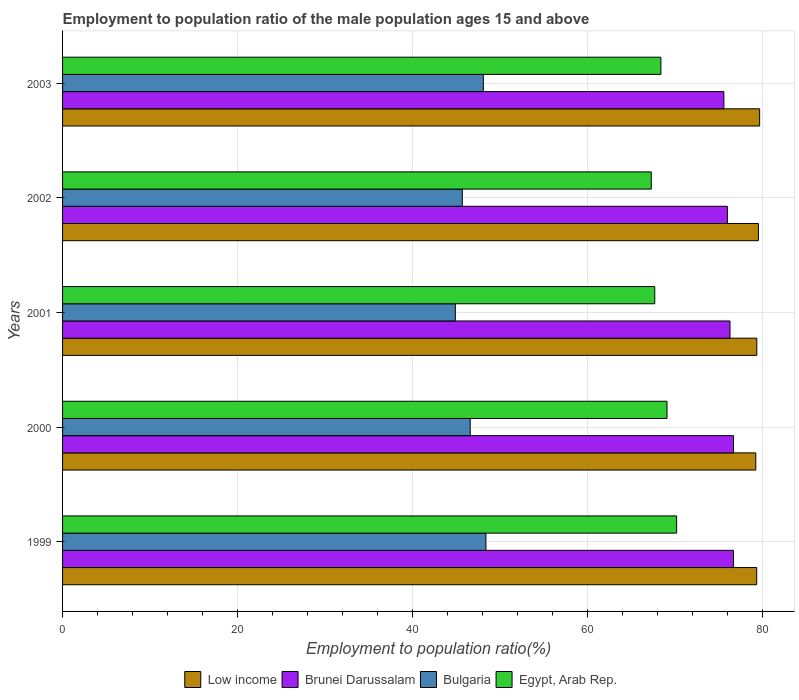Are the number of bars per tick equal to the number of legend labels?
Offer a very short reply. Yes. What is the label of the 3rd group of bars from the top?
Your answer should be compact. 2001. What is the employment to population ratio in Egypt, Arab Rep. in 1999?
Make the answer very short. 70.2. Across all years, what is the maximum employment to population ratio in Brunei Darussalam?
Your response must be concise. 76.7. Across all years, what is the minimum employment to population ratio in Bulgaria?
Your answer should be compact. 44.9. In which year was the employment to population ratio in Bulgaria maximum?
Provide a succinct answer. 1999. What is the total employment to population ratio in Low income in the graph?
Provide a short and direct response. 397.2. What is the difference between the employment to population ratio in Bulgaria in 1999 and that in 2001?
Your answer should be very brief. 3.5. What is the difference between the employment to population ratio in Bulgaria in 2001 and the employment to population ratio in Low income in 2003?
Provide a succinct answer. -34.79. What is the average employment to population ratio in Brunei Darussalam per year?
Offer a terse response. 76.26. In the year 1999, what is the difference between the employment to population ratio in Bulgaria and employment to population ratio in Low income?
Provide a succinct answer. -30.95. In how many years, is the employment to population ratio in Brunei Darussalam greater than 20 %?
Your answer should be compact. 5. What is the ratio of the employment to population ratio in Brunei Darussalam in 2001 to that in 2002?
Provide a succinct answer. 1. What is the difference between the highest and the second highest employment to population ratio in Low income?
Provide a short and direct response. 0.14. What is the difference between the highest and the lowest employment to population ratio in Low income?
Ensure brevity in your answer.  0.44. In how many years, is the employment to population ratio in Brunei Darussalam greater than the average employment to population ratio in Brunei Darussalam taken over all years?
Keep it short and to the point. 3. Is the sum of the employment to population ratio in Brunei Darussalam in 2000 and 2001 greater than the maximum employment to population ratio in Low income across all years?
Your response must be concise. Yes. What does the 3rd bar from the top in 2003 represents?
Your answer should be compact. Brunei Darussalam. What does the 2nd bar from the bottom in 2001 represents?
Your answer should be very brief. Brunei Darussalam. Is it the case that in every year, the sum of the employment to population ratio in Low income and employment to population ratio in Brunei Darussalam is greater than the employment to population ratio in Bulgaria?
Your answer should be compact. Yes. What is the difference between two consecutive major ticks on the X-axis?
Your response must be concise. 20. Are the values on the major ticks of X-axis written in scientific E-notation?
Offer a very short reply. No. Where does the legend appear in the graph?
Offer a terse response. Bottom center. How many legend labels are there?
Your answer should be very brief. 4. How are the legend labels stacked?
Make the answer very short. Horizontal. What is the title of the graph?
Make the answer very short. Employment to population ratio of the male population ages 15 and above. What is the label or title of the Y-axis?
Provide a short and direct response. Years. What is the Employment to population ratio(%) in Low income in 1999?
Your answer should be very brief. 79.35. What is the Employment to population ratio(%) of Brunei Darussalam in 1999?
Make the answer very short. 76.7. What is the Employment to population ratio(%) of Bulgaria in 1999?
Ensure brevity in your answer.  48.4. What is the Employment to population ratio(%) of Egypt, Arab Rep. in 1999?
Make the answer very short. 70.2. What is the Employment to population ratio(%) in Low income in 2000?
Your answer should be compact. 79.25. What is the Employment to population ratio(%) in Brunei Darussalam in 2000?
Your response must be concise. 76.7. What is the Employment to population ratio(%) of Bulgaria in 2000?
Make the answer very short. 46.6. What is the Employment to population ratio(%) of Egypt, Arab Rep. in 2000?
Ensure brevity in your answer.  69.1. What is the Employment to population ratio(%) of Low income in 2001?
Keep it short and to the point. 79.36. What is the Employment to population ratio(%) in Brunei Darussalam in 2001?
Your response must be concise. 76.3. What is the Employment to population ratio(%) of Bulgaria in 2001?
Your response must be concise. 44.9. What is the Employment to population ratio(%) in Egypt, Arab Rep. in 2001?
Provide a succinct answer. 67.7. What is the Employment to population ratio(%) of Low income in 2002?
Give a very brief answer. 79.55. What is the Employment to population ratio(%) of Brunei Darussalam in 2002?
Offer a terse response. 76. What is the Employment to population ratio(%) of Bulgaria in 2002?
Ensure brevity in your answer.  45.7. What is the Employment to population ratio(%) in Egypt, Arab Rep. in 2002?
Your answer should be compact. 67.3. What is the Employment to population ratio(%) of Low income in 2003?
Your response must be concise. 79.69. What is the Employment to population ratio(%) of Brunei Darussalam in 2003?
Offer a very short reply. 75.6. What is the Employment to population ratio(%) of Bulgaria in 2003?
Make the answer very short. 48.1. What is the Employment to population ratio(%) in Egypt, Arab Rep. in 2003?
Give a very brief answer. 68.4. Across all years, what is the maximum Employment to population ratio(%) of Low income?
Keep it short and to the point. 79.69. Across all years, what is the maximum Employment to population ratio(%) in Brunei Darussalam?
Give a very brief answer. 76.7. Across all years, what is the maximum Employment to population ratio(%) of Bulgaria?
Provide a succinct answer. 48.4. Across all years, what is the maximum Employment to population ratio(%) of Egypt, Arab Rep.?
Your answer should be compact. 70.2. Across all years, what is the minimum Employment to population ratio(%) of Low income?
Provide a short and direct response. 79.25. Across all years, what is the minimum Employment to population ratio(%) of Brunei Darussalam?
Keep it short and to the point. 75.6. Across all years, what is the minimum Employment to population ratio(%) of Bulgaria?
Your response must be concise. 44.9. Across all years, what is the minimum Employment to population ratio(%) in Egypt, Arab Rep.?
Make the answer very short. 67.3. What is the total Employment to population ratio(%) in Low income in the graph?
Your answer should be compact. 397.2. What is the total Employment to population ratio(%) in Brunei Darussalam in the graph?
Your answer should be very brief. 381.3. What is the total Employment to population ratio(%) of Bulgaria in the graph?
Ensure brevity in your answer.  233.7. What is the total Employment to population ratio(%) in Egypt, Arab Rep. in the graph?
Offer a very short reply. 342.7. What is the difference between the Employment to population ratio(%) of Low income in 1999 and that in 2000?
Your response must be concise. 0.1. What is the difference between the Employment to population ratio(%) of Bulgaria in 1999 and that in 2000?
Ensure brevity in your answer.  1.8. What is the difference between the Employment to population ratio(%) in Egypt, Arab Rep. in 1999 and that in 2000?
Make the answer very short. 1.1. What is the difference between the Employment to population ratio(%) in Low income in 1999 and that in 2001?
Your response must be concise. -0.01. What is the difference between the Employment to population ratio(%) in Brunei Darussalam in 1999 and that in 2001?
Your answer should be compact. 0.4. What is the difference between the Employment to population ratio(%) in Bulgaria in 1999 and that in 2001?
Your answer should be compact. 3.5. What is the difference between the Employment to population ratio(%) of Low income in 1999 and that in 2002?
Your answer should be very brief. -0.2. What is the difference between the Employment to population ratio(%) in Bulgaria in 1999 and that in 2002?
Ensure brevity in your answer.  2.7. What is the difference between the Employment to population ratio(%) of Egypt, Arab Rep. in 1999 and that in 2002?
Your answer should be very brief. 2.9. What is the difference between the Employment to population ratio(%) in Low income in 1999 and that in 2003?
Keep it short and to the point. -0.34. What is the difference between the Employment to population ratio(%) in Low income in 2000 and that in 2001?
Your response must be concise. -0.11. What is the difference between the Employment to population ratio(%) in Brunei Darussalam in 2000 and that in 2001?
Offer a terse response. 0.4. What is the difference between the Employment to population ratio(%) in Bulgaria in 2000 and that in 2001?
Your response must be concise. 1.7. What is the difference between the Employment to population ratio(%) in Egypt, Arab Rep. in 2000 and that in 2001?
Offer a very short reply. 1.4. What is the difference between the Employment to population ratio(%) in Low income in 2000 and that in 2002?
Provide a short and direct response. -0.3. What is the difference between the Employment to population ratio(%) of Bulgaria in 2000 and that in 2002?
Offer a terse response. 0.9. What is the difference between the Employment to population ratio(%) of Egypt, Arab Rep. in 2000 and that in 2002?
Ensure brevity in your answer.  1.8. What is the difference between the Employment to population ratio(%) in Low income in 2000 and that in 2003?
Your answer should be very brief. -0.44. What is the difference between the Employment to population ratio(%) of Bulgaria in 2000 and that in 2003?
Give a very brief answer. -1.5. What is the difference between the Employment to population ratio(%) of Egypt, Arab Rep. in 2000 and that in 2003?
Offer a terse response. 0.7. What is the difference between the Employment to population ratio(%) in Low income in 2001 and that in 2002?
Your answer should be compact. -0.18. What is the difference between the Employment to population ratio(%) in Low income in 2001 and that in 2003?
Your answer should be very brief. -0.33. What is the difference between the Employment to population ratio(%) in Egypt, Arab Rep. in 2001 and that in 2003?
Your answer should be compact. -0.7. What is the difference between the Employment to population ratio(%) of Low income in 2002 and that in 2003?
Offer a very short reply. -0.14. What is the difference between the Employment to population ratio(%) in Brunei Darussalam in 2002 and that in 2003?
Your answer should be compact. 0.4. What is the difference between the Employment to population ratio(%) in Egypt, Arab Rep. in 2002 and that in 2003?
Provide a succinct answer. -1.1. What is the difference between the Employment to population ratio(%) in Low income in 1999 and the Employment to population ratio(%) in Brunei Darussalam in 2000?
Offer a terse response. 2.65. What is the difference between the Employment to population ratio(%) of Low income in 1999 and the Employment to population ratio(%) of Bulgaria in 2000?
Provide a short and direct response. 32.75. What is the difference between the Employment to population ratio(%) in Low income in 1999 and the Employment to population ratio(%) in Egypt, Arab Rep. in 2000?
Offer a very short reply. 10.25. What is the difference between the Employment to population ratio(%) in Brunei Darussalam in 1999 and the Employment to population ratio(%) in Bulgaria in 2000?
Your response must be concise. 30.1. What is the difference between the Employment to population ratio(%) in Bulgaria in 1999 and the Employment to population ratio(%) in Egypt, Arab Rep. in 2000?
Give a very brief answer. -20.7. What is the difference between the Employment to population ratio(%) of Low income in 1999 and the Employment to population ratio(%) of Brunei Darussalam in 2001?
Offer a terse response. 3.05. What is the difference between the Employment to population ratio(%) in Low income in 1999 and the Employment to population ratio(%) in Bulgaria in 2001?
Provide a succinct answer. 34.45. What is the difference between the Employment to population ratio(%) in Low income in 1999 and the Employment to population ratio(%) in Egypt, Arab Rep. in 2001?
Your answer should be very brief. 11.65. What is the difference between the Employment to population ratio(%) of Brunei Darussalam in 1999 and the Employment to population ratio(%) of Bulgaria in 2001?
Ensure brevity in your answer.  31.8. What is the difference between the Employment to population ratio(%) in Brunei Darussalam in 1999 and the Employment to population ratio(%) in Egypt, Arab Rep. in 2001?
Make the answer very short. 9. What is the difference between the Employment to population ratio(%) in Bulgaria in 1999 and the Employment to population ratio(%) in Egypt, Arab Rep. in 2001?
Ensure brevity in your answer.  -19.3. What is the difference between the Employment to population ratio(%) of Low income in 1999 and the Employment to population ratio(%) of Brunei Darussalam in 2002?
Offer a very short reply. 3.35. What is the difference between the Employment to population ratio(%) in Low income in 1999 and the Employment to population ratio(%) in Bulgaria in 2002?
Give a very brief answer. 33.65. What is the difference between the Employment to population ratio(%) of Low income in 1999 and the Employment to population ratio(%) of Egypt, Arab Rep. in 2002?
Ensure brevity in your answer.  12.05. What is the difference between the Employment to population ratio(%) of Brunei Darussalam in 1999 and the Employment to population ratio(%) of Egypt, Arab Rep. in 2002?
Provide a short and direct response. 9.4. What is the difference between the Employment to population ratio(%) of Bulgaria in 1999 and the Employment to population ratio(%) of Egypt, Arab Rep. in 2002?
Make the answer very short. -18.9. What is the difference between the Employment to population ratio(%) of Low income in 1999 and the Employment to population ratio(%) of Brunei Darussalam in 2003?
Provide a short and direct response. 3.75. What is the difference between the Employment to population ratio(%) in Low income in 1999 and the Employment to population ratio(%) in Bulgaria in 2003?
Ensure brevity in your answer.  31.25. What is the difference between the Employment to population ratio(%) in Low income in 1999 and the Employment to population ratio(%) in Egypt, Arab Rep. in 2003?
Your answer should be very brief. 10.95. What is the difference between the Employment to population ratio(%) of Brunei Darussalam in 1999 and the Employment to population ratio(%) of Bulgaria in 2003?
Offer a very short reply. 28.6. What is the difference between the Employment to population ratio(%) in Brunei Darussalam in 1999 and the Employment to population ratio(%) in Egypt, Arab Rep. in 2003?
Your answer should be compact. 8.3. What is the difference between the Employment to population ratio(%) in Bulgaria in 1999 and the Employment to population ratio(%) in Egypt, Arab Rep. in 2003?
Give a very brief answer. -20. What is the difference between the Employment to population ratio(%) of Low income in 2000 and the Employment to population ratio(%) of Brunei Darussalam in 2001?
Keep it short and to the point. 2.95. What is the difference between the Employment to population ratio(%) of Low income in 2000 and the Employment to population ratio(%) of Bulgaria in 2001?
Offer a very short reply. 34.35. What is the difference between the Employment to population ratio(%) in Low income in 2000 and the Employment to population ratio(%) in Egypt, Arab Rep. in 2001?
Offer a very short reply. 11.55. What is the difference between the Employment to population ratio(%) of Brunei Darussalam in 2000 and the Employment to population ratio(%) of Bulgaria in 2001?
Give a very brief answer. 31.8. What is the difference between the Employment to population ratio(%) of Bulgaria in 2000 and the Employment to population ratio(%) of Egypt, Arab Rep. in 2001?
Keep it short and to the point. -21.1. What is the difference between the Employment to population ratio(%) in Low income in 2000 and the Employment to population ratio(%) in Brunei Darussalam in 2002?
Your response must be concise. 3.25. What is the difference between the Employment to population ratio(%) of Low income in 2000 and the Employment to population ratio(%) of Bulgaria in 2002?
Provide a short and direct response. 33.55. What is the difference between the Employment to population ratio(%) in Low income in 2000 and the Employment to population ratio(%) in Egypt, Arab Rep. in 2002?
Ensure brevity in your answer.  11.95. What is the difference between the Employment to population ratio(%) in Bulgaria in 2000 and the Employment to population ratio(%) in Egypt, Arab Rep. in 2002?
Your answer should be very brief. -20.7. What is the difference between the Employment to population ratio(%) of Low income in 2000 and the Employment to population ratio(%) of Brunei Darussalam in 2003?
Make the answer very short. 3.65. What is the difference between the Employment to population ratio(%) in Low income in 2000 and the Employment to population ratio(%) in Bulgaria in 2003?
Give a very brief answer. 31.15. What is the difference between the Employment to population ratio(%) of Low income in 2000 and the Employment to population ratio(%) of Egypt, Arab Rep. in 2003?
Keep it short and to the point. 10.85. What is the difference between the Employment to population ratio(%) in Brunei Darussalam in 2000 and the Employment to population ratio(%) in Bulgaria in 2003?
Your answer should be compact. 28.6. What is the difference between the Employment to population ratio(%) in Brunei Darussalam in 2000 and the Employment to population ratio(%) in Egypt, Arab Rep. in 2003?
Your answer should be compact. 8.3. What is the difference between the Employment to population ratio(%) of Bulgaria in 2000 and the Employment to population ratio(%) of Egypt, Arab Rep. in 2003?
Ensure brevity in your answer.  -21.8. What is the difference between the Employment to population ratio(%) in Low income in 2001 and the Employment to population ratio(%) in Brunei Darussalam in 2002?
Ensure brevity in your answer.  3.36. What is the difference between the Employment to population ratio(%) in Low income in 2001 and the Employment to population ratio(%) in Bulgaria in 2002?
Make the answer very short. 33.66. What is the difference between the Employment to population ratio(%) in Low income in 2001 and the Employment to population ratio(%) in Egypt, Arab Rep. in 2002?
Offer a very short reply. 12.06. What is the difference between the Employment to population ratio(%) of Brunei Darussalam in 2001 and the Employment to population ratio(%) of Bulgaria in 2002?
Make the answer very short. 30.6. What is the difference between the Employment to population ratio(%) in Bulgaria in 2001 and the Employment to population ratio(%) in Egypt, Arab Rep. in 2002?
Keep it short and to the point. -22.4. What is the difference between the Employment to population ratio(%) of Low income in 2001 and the Employment to population ratio(%) of Brunei Darussalam in 2003?
Ensure brevity in your answer.  3.76. What is the difference between the Employment to population ratio(%) in Low income in 2001 and the Employment to population ratio(%) in Bulgaria in 2003?
Your response must be concise. 31.26. What is the difference between the Employment to population ratio(%) of Low income in 2001 and the Employment to population ratio(%) of Egypt, Arab Rep. in 2003?
Give a very brief answer. 10.96. What is the difference between the Employment to population ratio(%) of Brunei Darussalam in 2001 and the Employment to population ratio(%) of Bulgaria in 2003?
Offer a terse response. 28.2. What is the difference between the Employment to population ratio(%) in Bulgaria in 2001 and the Employment to population ratio(%) in Egypt, Arab Rep. in 2003?
Give a very brief answer. -23.5. What is the difference between the Employment to population ratio(%) in Low income in 2002 and the Employment to population ratio(%) in Brunei Darussalam in 2003?
Your answer should be compact. 3.95. What is the difference between the Employment to population ratio(%) of Low income in 2002 and the Employment to population ratio(%) of Bulgaria in 2003?
Your answer should be compact. 31.45. What is the difference between the Employment to population ratio(%) of Low income in 2002 and the Employment to population ratio(%) of Egypt, Arab Rep. in 2003?
Provide a succinct answer. 11.15. What is the difference between the Employment to population ratio(%) of Brunei Darussalam in 2002 and the Employment to population ratio(%) of Bulgaria in 2003?
Provide a short and direct response. 27.9. What is the difference between the Employment to population ratio(%) in Bulgaria in 2002 and the Employment to population ratio(%) in Egypt, Arab Rep. in 2003?
Offer a very short reply. -22.7. What is the average Employment to population ratio(%) of Low income per year?
Provide a succinct answer. 79.44. What is the average Employment to population ratio(%) in Brunei Darussalam per year?
Keep it short and to the point. 76.26. What is the average Employment to population ratio(%) in Bulgaria per year?
Keep it short and to the point. 46.74. What is the average Employment to population ratio(%) of Egypt, Arab Rep. per year?
Your answer should be very brief. 68.54. In the year 1999, what is the difference between the Employment to population ratio(%) of Low income and Employment to population ratio(%) of Brunei Darussalam?
Provide a succinct answer. 2.65. In the year 1999, what is the difference between the Employment to population ratio(%) in Low income and Employment to population ratio(%) in Bulgaria?
Your answer should be compact. 30.95. In the year 1999, what is the difference between the Employment to population ratio(%) of Low income and Employment to population ratio(%) of Egypt, Arab Rep.?
Keep it short and to the point. 9.15. In the year 1999, what is the difference between the Employment to population ratio(%) of Brunei Darussalam and Employment to population ratio(%) of Bulgaria?
Your answer should be compact. 28.3. In the year 1999, what is the difference between the Employment to population ratio(%) of Bulgaria and Employment to population ratio(%) of Egypt, Arab Rep.?
Keep it short and to the point. -21.8. In the year 2000, what is the difference between the Employment to population ratio(%) of Low income and Employment to population ratio(%) of Brunei Darussalam?
Ensure brevity in your answer.  2.55. In the year 2000, what is the difference between the Employment to population ratio(%) in Low income and Employment to population ratio(%) in Bulgaria?
Ensure brevity in your answer.  32.65. In the year 2000, what is the difference between the Employment to population ratio(%) of Low income and Employment to population ratio(%) of Egypt, Arab Rep.?
Give a very brief answer. 10.15. In the year 2000, what is the difference between the Employment to population ratio(%) in Brunei Darussalam and Employment to population ratio(%) in Bulgaria?
Your answer should be compact. 30.1. In the year 2000, what is the difference between the Employment to population ratio(%) of Brunei Darussalam and Employment to population ratio(%) of Egypt, Arab Rep.?
Make the answer very short. 7.6. In the year 2000, what is the difference between the Employment to population ratio(%) of Bulgaria and Employment to population ratio(%) of Egypt, Arab Rep.?
Give a very brief answer. -22.5. In the year 2001, what is the difference between the Employment to population ratio(%) of Low income and Employment to population ratio(%) of Brunei Darussalam?
Offer a very short reply. 3.06. In the year 2001, what is the difference between the Employment to population ratio(%) in Low income and Employment to population ratio(%) in Bulgaria?
Make the answer very short. 34.46. In the year 2001, what is the difference between the Employment to population ratio(%) of Low income and Employment to population ratio(%) of Egypt, Arab Rep.?
Ensure brevity in your answer.  11.66. In the year 2001, what is the difference between the Employment to population ratio(%) of Brunei Darussalam and Employment to population ratio(%) of Bulgaria?
Ensure brevity in your answer.  31.4. In the year 2001, what is the difference between the Employment to population ratio(%) of Brunei Darussalam and Employment to population ratio(%) of Egypt, Arab Rep.?
Your answer should be compact. 8.6. In the year 2001, what is the difference between the Employment to population ratio(%) of Bulgaria and Employment to population ratio(%) of Egypt, Arab Rep.?
Ensure brevity in your answer.  -22.8. In the year 2002, what is the difference between the Employment to population ratio(%) in Low income and Employment to population ratio(%) in Brunei Darussalam?
Your response must be concise. 3.55. In the year 2002, what is the difference between the Employment to population ratio(%) of Low income and Employment to population ratio(%) of Bulgaria?
Your answer should be compact. 33.85. In the year 2002, what is the difference between the Employment to population ratio(%) of Low income and Employment to population ratio(%) of Egypt, Arab Rep.?
Your answer should be compact. 12.25. In the year 2002, what is the difference between the Employment to population ratio(%) of Brunei Darussalam and Employment to population ratio(%) of Bulgaria?
Offer a terse response. 30.3. In the year 2002, what is the difference between the Employment to population ratio(%) of Bulgaria and Employment to population ratio(%) of Egypt, Arab Rep.?
Give a very brief answer. -21.6. In the year 2003, what is the difference between the Employment to population ratio(%) of Low income and Employment to population ratio(%) of Brunei Darussalam?
Your response must be concise. 4.09. In the year 2003, what is the difference between the Employment to population ratio(%) in Low income and Employment to population ratio(%) in Bulgaria?
Keep it short and to the point. 31.59. In the year 2003, what is the difference between the Employment to population ratio(%) in Low income and Employment to population ratio(%) in Egypt, Arab Rep.?
Offer a terse response. 11.29. In the year 2003, what is the difference between the Employment to population ratio(%) in Bulgaria and Employment to population ratio(%) in Egypt, Arab Rep.?
Ensure brevity in your answer.  -20.3. What is the ratio of the Employment to population ratio(%) of Low income in 1999 to that in 2000?
Provide a succinct answer. 1. What is the ratio of the Employment to population ratio(%) in Bulgaria in 1999 to that in 2000?
Keep it short and to the point. 1.04. What is the ratio of the Employment to population ratio(%) in Egypt, Arab Rep. in 1999 to that in 2000?
Keep it short and to the point. 1.02. What is the ratio of the Employment to population ratio(%) of Low income in 1999 to that in 2001?
Offer a terse response. 1. What is the ratio of the Employment to population ratio(%) of Bulgaria in 1999 to that in 2001?
Your response must be concise. 1.08. What is the ratio of the Employment to population ratio(%) of Egypt, Arab Rep. in 1999 to that in 2001?
Ensure brevity in your answer.  1.04. What is the ratio of the Employment to population ratio(%) of Brunei Darussalam in 1999 to that in 2002?
Ensure brevity in your answer.  1.01. What is the ratio of the Employment to population ratio(%) in Bulgaria in 1999 to that in 2002?
Make the answer very short. 1.06. What is the ratio of the Employment to population ratio(%) in Egypt, Arab Rep. in 1999 to that in 2002?
Make the answer very short. 1.04. What is the ratio of the Employment to population ratio(%) in Brunei Darussalam in 1999 to that in 2003?
Provide a succinct answer. 1.01. What is the ratio of the Employment to population ratio(%) of Bulgaria in 1999 to that in 2003?
Your response must be concise. 1.01. What is the ratio of the Employment to population ratio(%) of Egypt, Arab Rep. in 1999 to that in 2003?
Make the answer very short. 1.03. What is the ratio of the Employment to population ratio(%) of Low income in 2000 to that in 2001?
Offer a terse response. 1. What is the ratio of the Employment to population ratio(%) in Bulgaria in 2000 to that in 2001?
Offer a terse response. 1.04. What is the ratio of the Employment to population ratio(%) in Egypt, Arab Rep. in 2000 to that in 2001?
Provide a succinct answer. 1.02. What is the ratio of the Employment to population ratio(%) in Low income in 2000 to that in 2002?
Your response must be concise. 1. What is the ratio of the Employment to population ratio(%) in Brunei Darussalam in 2000 to that in 2002?
Provide a succinct answer. 1.01. What is the ratio of the Employment to population ratio(%) in Bulgaria in 2000 to that in 2002?
Your answer should be compact. 1.02. What is the ratio of the Employment to population ratio(%) in Egypt, Arab Rep. in 2000 to that in 2002?
Offer a very short reply. 1.03. What is the ratio of the Employment to population ratio(%) of Low income in 2000 to that in 2003?
Keep it short and to the point. 0.99. What is the ratio of the Employment to population ratio(%) in Brunei Darussalam in 2000 to that in 2003?
Provide a succinct answer. 1.01. What is the ratio of the Employment to population ratio(%) of Bulgaria in 2000 to that in 2003?
Make the answer very short. 0.97. What is the ratio of the Employment to population ratio(%) of Egypt, Arab Rep. in 2000 to that in 2003?
Make the answer very short. 1.01. What is the ratio of the Employment to population ratio(%) in Low income in 2001 to that in 2002?
Your answer should be very brief. 1. What is the ratio of the Employment to population ratio(%) of Bulgaria in 2001 to that in 2002?
Provide a succinct answer. 0.98. What is the ratio of the Employment to population ratio(%) of Egypt, Arab Rep. in 2001 to that in 2002?
Your response must be concise. 1.01. What is the ratio of the Employment to population ratio(%) in Brunei Darussalam in 2001 to that in 2003?
Offer a terse response. 1.01. What is the ratio of the Employment to population ratio(%) in Bulgaria in 2001 to that in 2003?
Provide a succinct answer. 0.93. What is the ratio of the Employment to population ratio(%) in Egypt, Arab Rep. in 2001 to that in 2003?
Ensure brevity in your answer.  0.99. What is the ratio of the Employment to population ratio(%) in Brunei Darussalam in 2002 to that in 2003?
Give a very brief answer. 1.01. What is the ratio of the Employment to population ratio(%) of Bulgaria in 2002 to that in 2003?
Offer a terse response. 0.95. What is the ratio of the Employment to population ratio(%) in Egypt, Arab Rep. in 2002 to that in 2003?
Keep it short and to the point. 0.98. What is the difference between the highest and the second highest Employment to population ratio(%) of Low income?
Offer a very short reply. 0.14. What is the difference between the highest and the second highest Employment to population ratio(%) of Egypt, Arab Rep.?
Your answer should be compact. 1.1. What is the difference between the highest and the lowest Employment to population ratio(%) of Low income?
Your answer should be compact. 0.44. What is the difference between the highest and the lowest Employment to population ratio(%) in Bulgaria?
Your response must be concise. 3.5. 